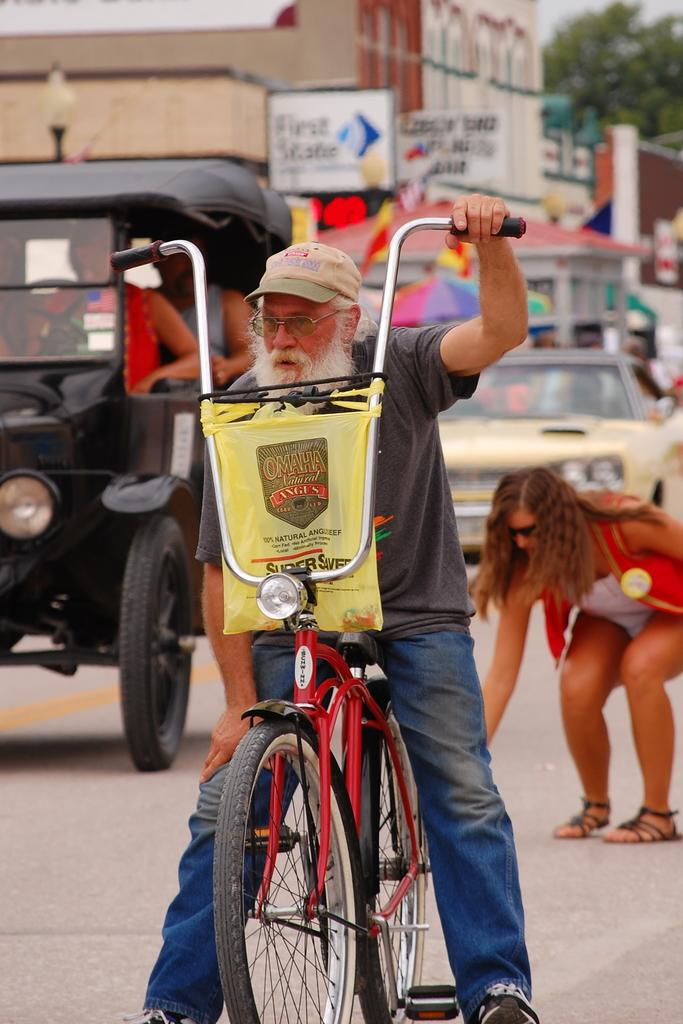Who is present in the image? There is a man in the image. What is the man doing in the image? The man is with his cycle in the image. Can you describe the man's attire? The man is wearing a cap and specs in the image. What can be seen in the background of the image? There are people and vehicles in the background of the image. What type of memory does the man have in the image? There is no mention of a memory in the image; the man is with his cycle and wearing a cap and specs. Is the man in the image in prison? There is no indication of the man being in prison in the image; he is with his cycle and there are no prison-related elements present. 